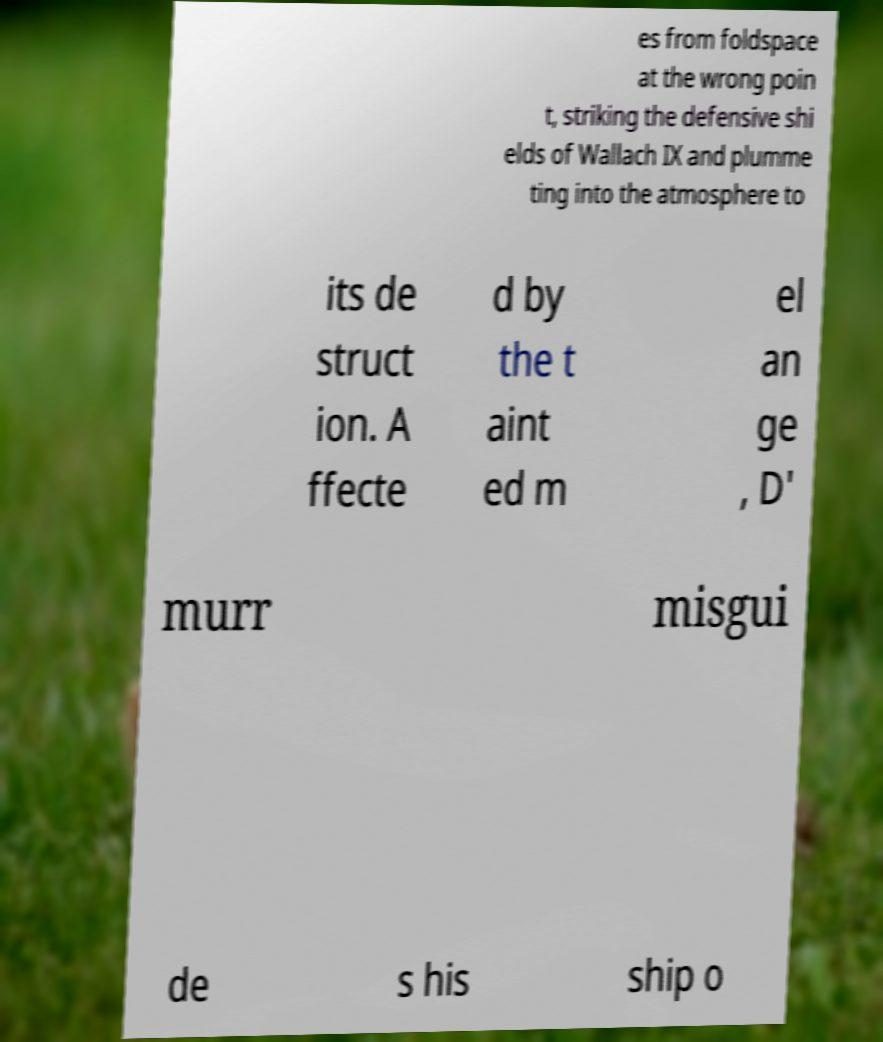Can you read and provide the text displayed in the image?This photo seems to have some interesting text. Can you extract and type it out for me? es from foldspace at the wrong poin t, striking the defensive shi elds of Wallach IX and plumme ting into the atmosphere to its de struct ion. A ffecte d by the t aint ed m el an ge , D' murr misgui de s his ship o 